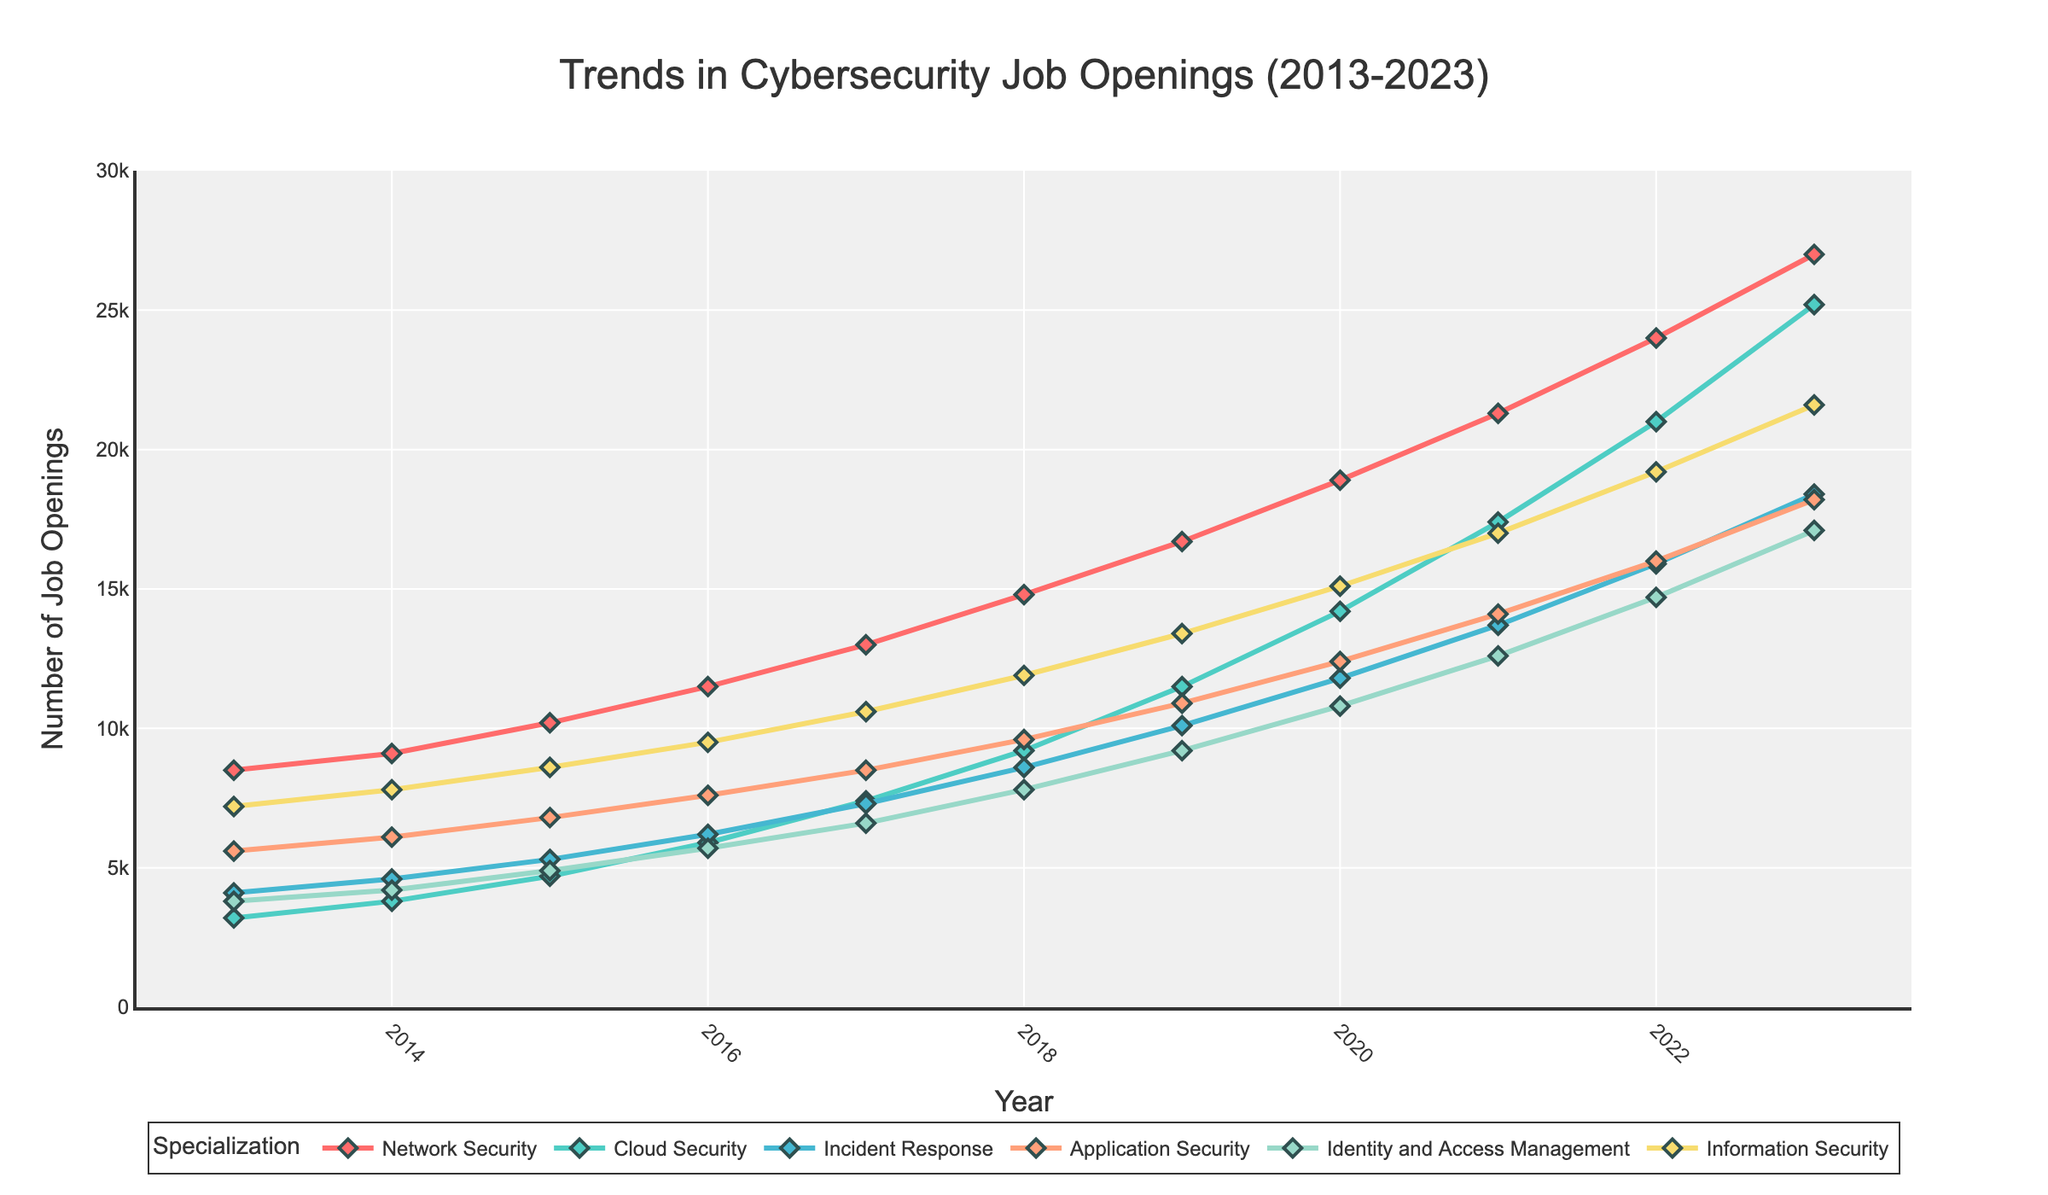What is the overall trend for Network Security job openings? The number of Network Security job openings has steadily increased from 2013 to 2023. It started at 8,500 in 2013 and rose to 27,000 in 2023.
Answer: The trend is an overall increase Which specialization saw the highest number of job openings in 2023? In the year 2023, the specialization with the highest number of job openings is Network Security, reaching 27,000 openings.
Answer: Network Security Compare the job trends between Application Security and Identity and Access Management from 2018 to 2023. Which grew faster? From 2018 to 2023, job openings for Application Security increased from 9,600 to 18,200, a difference of 8,600. For Identity and Access Management, openings increased from 7,800 to 17,100, a difference of 9,300. Therefore, Identity and Access Management grew faster.
Answer: Identity and Access Management What is the average number of job openings for Incident Response over the decade? The numbers for Incident Response openings are: 4100, 4600, 5300, 6200, 7300, 8600, 10100, 11800, 13700, 15900, 18400. Summing these gives 112500. There are 11 years, so the average is 112500 / 11 = 10227.
Answer: 10227 What is the difference in job openings between Cloud Security and Information Security in 2021? In 2021, Cloud Security had 17,400 job openings, while Information Security had 17,000. The difference is 17,400 - 17,000 = 400.
Answer: 400 Which specialization had the most consistent growth throughout the years, based on the visual lines? By examining the smoothness and steady incline of the lines, Application Security and Network Security show the most consistent growth over the years.
Answer: Application Security and Network Security What were the job openings for Identity and Access Management in 2013 and 2023? In 2013, Identity and Access Management had 3,800 job openings, and in 2023, it had 17,100 job openings.
Answer: 3,800 and 17,100 Compare the job growth trends of Network Security and Cloud Security from 2013 to 2023. By what factor did each increase? Network Security grew from 8,500 to 27,000, approximately a 3.18-fold increase (27,000 / 8,500). Cloud Security grew from 3,200 to 25,200, approximately a 7.88-fold increase (25,200 / 3,200). Cloud Security had a higher factor of increase.
Answer: Network Security: 3.18, Cloud Security: 7.88 By how much did Information Security job openings increase from 2017 to 2023? In 2017, Information Security had 10,600 job openings. In 2023, it had 21,600 job openings. The increase is 21,600 - 10,600 = 11,000.
Answer: 11,000 What are the visual differences in the markers used for different specializations in the plot? Each specialization line on the plot is marked with diamonds of different colors. For example, Network Security uses red, Cloud Security uses green, etc. All markers have an outline colored in DarkSlateGrey.
Answer: Different colored diamonds with DarkSlateGrey outlines 